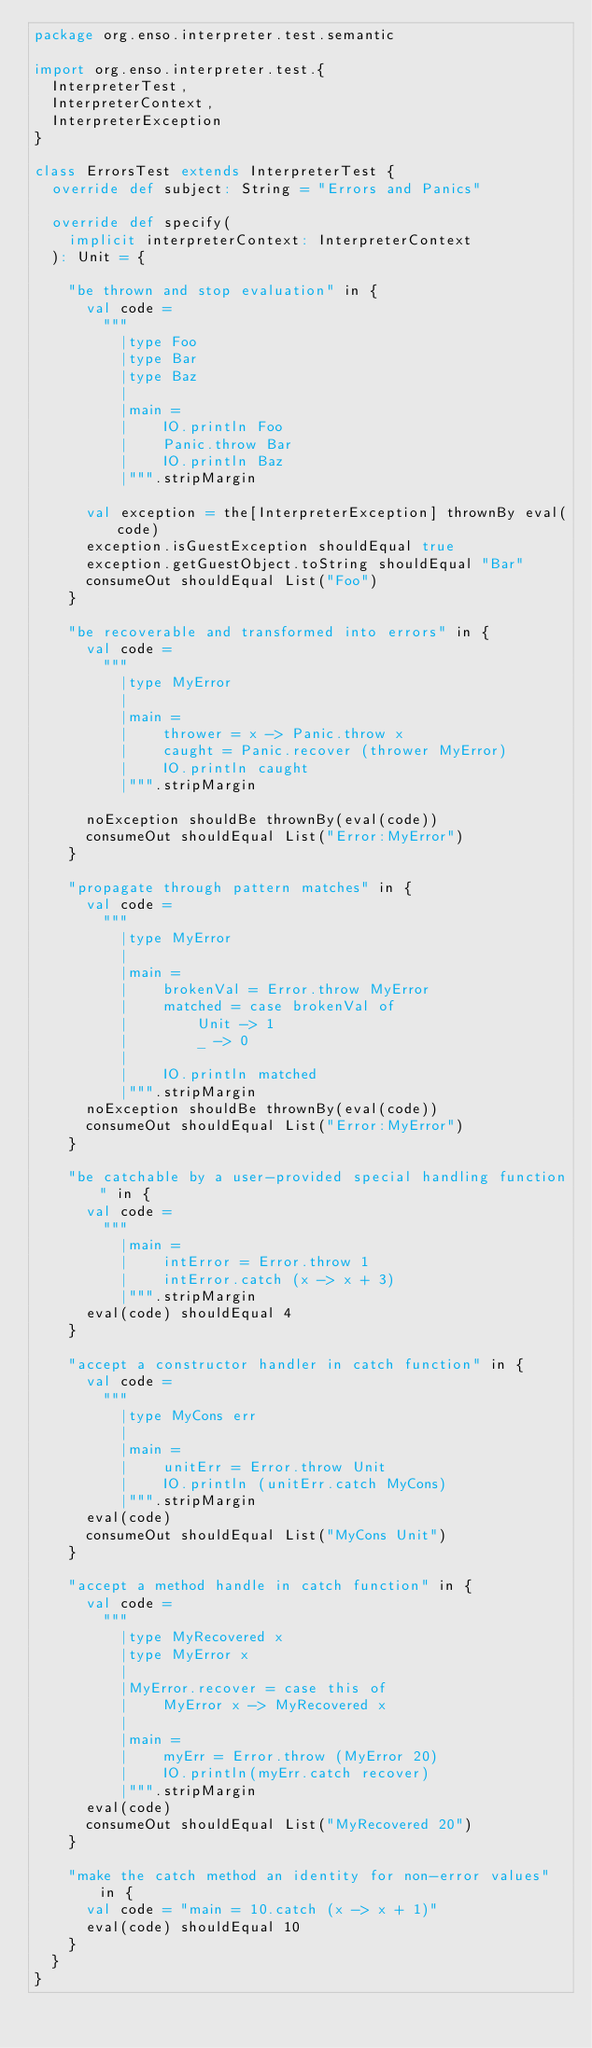<code> <loc_0><loc_0><loc_500><loc_500><_Scala_>package org.enso.interpreter.test.semantic

import org.enso.interpreter.test.{
  InterpreterTest,
  InterpreterContext,
  InterpreterException
}

class ErrorsTest extends InterpreterTest {
  override def subject: String = "Errors and Panics"

  override def specify(
    implicit interpreterContext: InterpreterContext
  ): Unit = {

    "be thrown and stop evaluation" in {
      val code =
        """
          |type Foo
          |type Bar
          |type Baz
          |
          |main =
          |    IO.println Foo
          |    Panic.throw Bar
          |    IO.println Baz
          |""".stripMargin

      val exception = the[InterpreterException] thrownBy eval(code)
      exception.isGuestException shouldEqual true
      exception.getGuestObject.toString shouldEqual "Bar"
      consumeOut shouldEqual List("Foo")
    }

    "be recoverable and transformed into errors" in {
      val code =
        """
          |type MyError
          |
          |main =
          |    thrower = x -> Panic.throw x
          |    caught = Panic.recover (thrower MyError)
          |    IO.println caught
          |""".stripMargin

      noException shouldBe thrownBy(eval(code))
      consumeOut shouldEqual List("Error:MyError")
    }

    "propagate through pattern matches" in {
      val code =
        """
          |type MyError
          |
          |main =
          |    brokenVal = Error.throw MyError
          |    matched = case brokenVal of
          |        Unit -> 1
          |        _ -> 0
          |
          |    IO.println matched
          |""".stripMargin
      noException shouldBe thrownBy(eval(code))
      consumeOut shouldEqual List("Error:MyError")
    }

    "be catchable by a user-provided special handling function" in {
      val code =
        """
          |main =
          |    intError = Error.throw 1
          |    intError.catch (x -> x + 3)
          |""".stripMargin
      eval(code) shouldEqual 4
    }

    "accept a constructor handler in catch function" in {
      val code =
        """
          |type MyCons err
          |
          |main =
          |    unitErr = Error.throw Unit
          |    IO.println (unitErr.catch MyCons)
          |""".stripMargin
      eval(code)
      consumeOut shouldEqual List("MyCons Unit")
    }

    "accept a method handle in catch function" in {
      val code =
        """
          |type MyRecovered x
          |type MyError x
          |
          |MyError.recover = case this of
          |    MyError x -> MyRecovered x
          |
          |main =
          |    myErr = Error.throw (MyError 20)
          |    IO.println(myErr.catch recover)
          |""".stripMargin
      eval(code)
      consumeOut shouldEqual List("MyRecovered 20")
    }

    "make the catch method an identity for non-error values" in {
      val code = "main = 10.catch (x -> x + 1)"
      eval(code) shouldEqual 10
    }
  }
}
</code> 